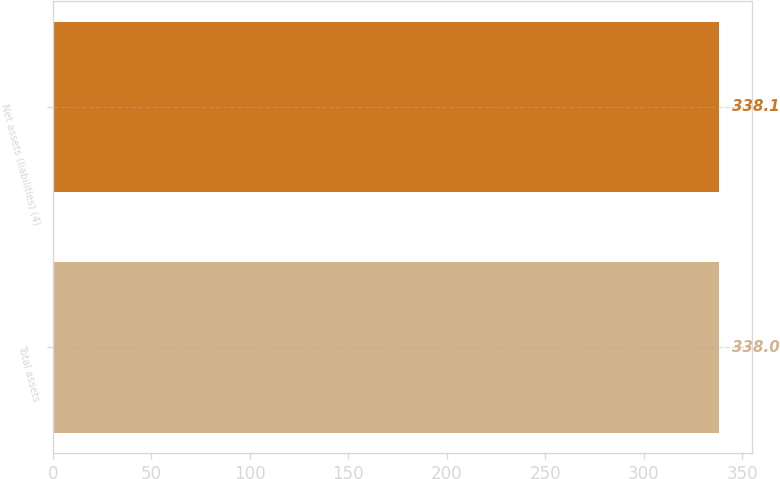<chart> <loc_0><loc_0><loc_500><loc_500><bar_chart><fcel>Total assets<fcel>Net assets (liabilities) (4)<nl><fcel>338<fcel>338.1<nl></chart> 